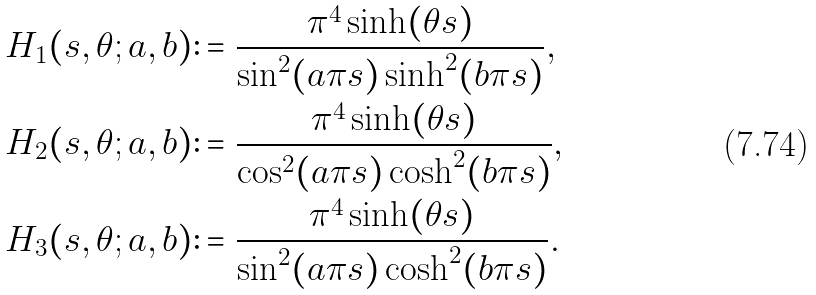Convert formula to latex. <formula><loc_0><loc_0><loc_500><loc_500>& H _ { 1 } ( s , \theta ; a , b ) \colon = \frac { \pi ^ { 4 } \sinh ( \theta s ) } { \sin ^ { 2 } ( a \pi s ) \sinh ^ { 2 } ( b \pi s ) } , \\ & H _ { 2 } ( s , \theta ; a , b ) \colon = \frac { \pi ^ { 4 } \sinh ( \theta s ) } { \cos ^ { 2 } ( a \pi s ) \cosh ^ { 2 } ( b \pi s ) } , \\ & H _ { 3 } ( s , \theta ; a , b ) \colon = \frac { \pi ^ { 4 } \sinh ( \theta s ) } { \sin ^ { 2 } ( a \pi s ) \cosh ^ { 2 } ( b \pi s ) } .</formula> 